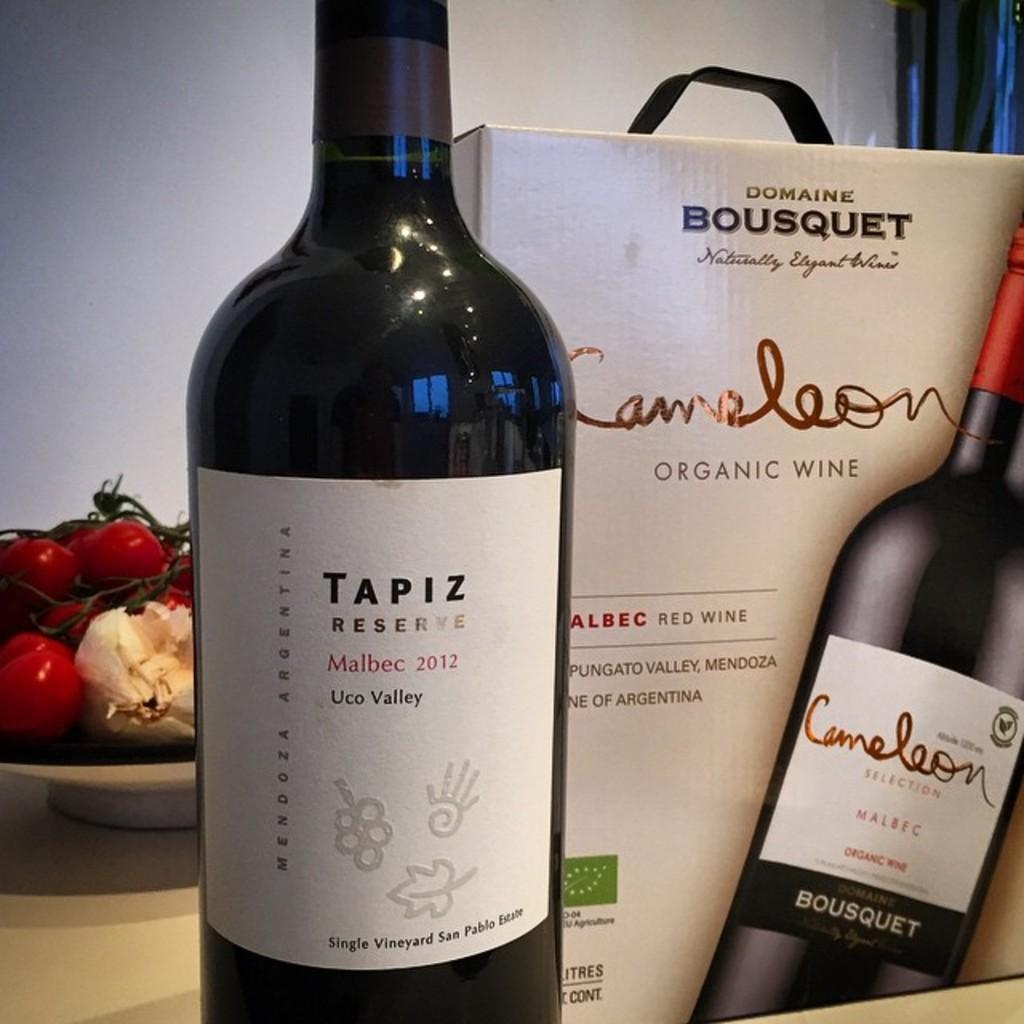What is the brand of wine here?
Provide a short and direct response. Tapiz. 